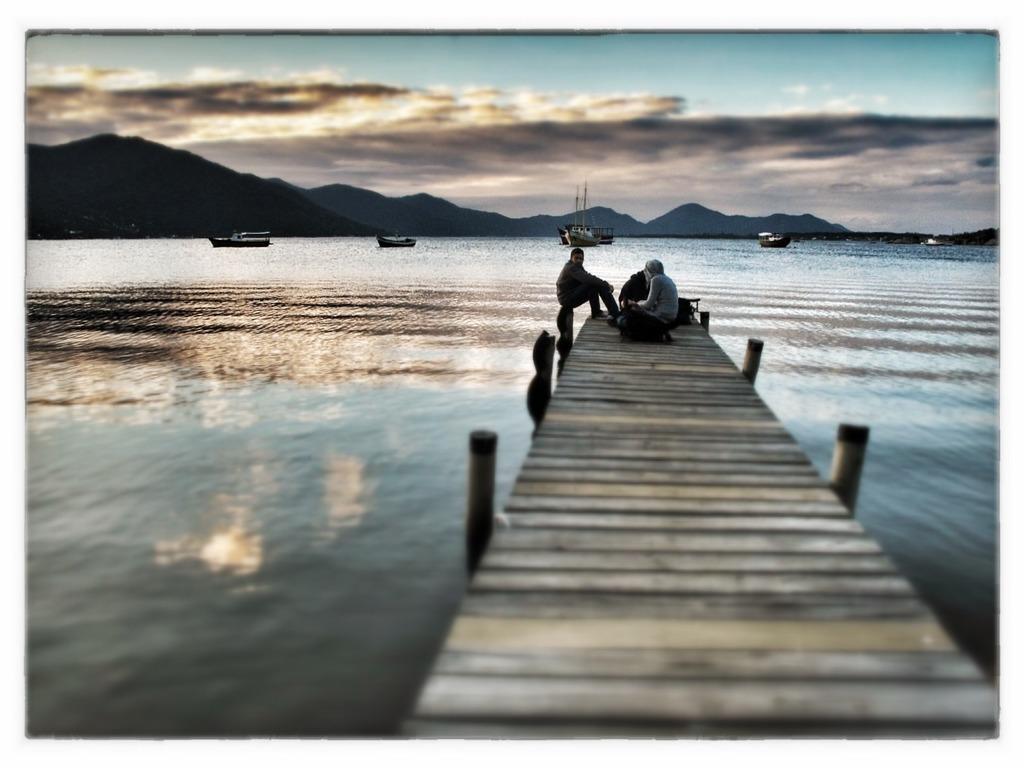In one or two sentences, can you explain what this image depicts? On the right side of the image we can see a walkway and there are people sitting on the walkway. In the background there is a river. We can see boats on the river. There are hills. At the top there is sky. 